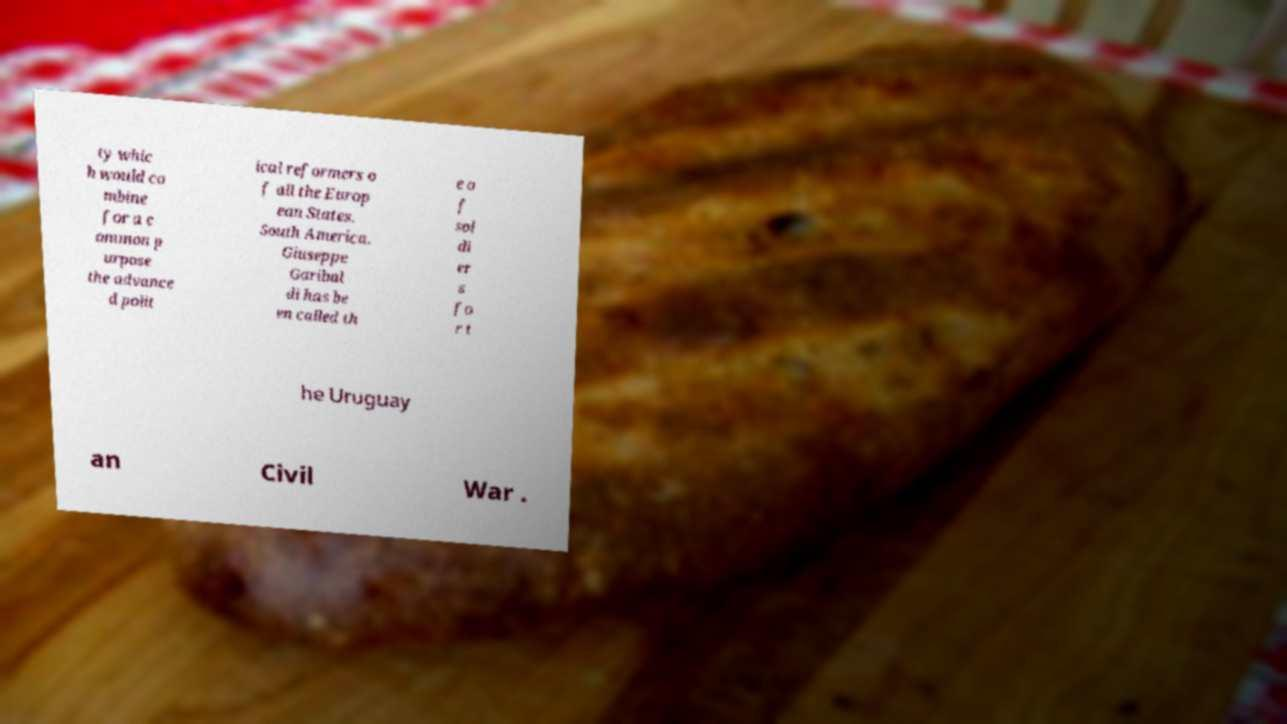Could you extract and type out the text from this image? ty whic h would co mbine for a c ommon p urpose the advance d polit ical reformers o f all the Europ ean States. South America. Giuseppe Garibal di has be en called th e o f sol di er s fo r t he Uruguay an Civil War . 